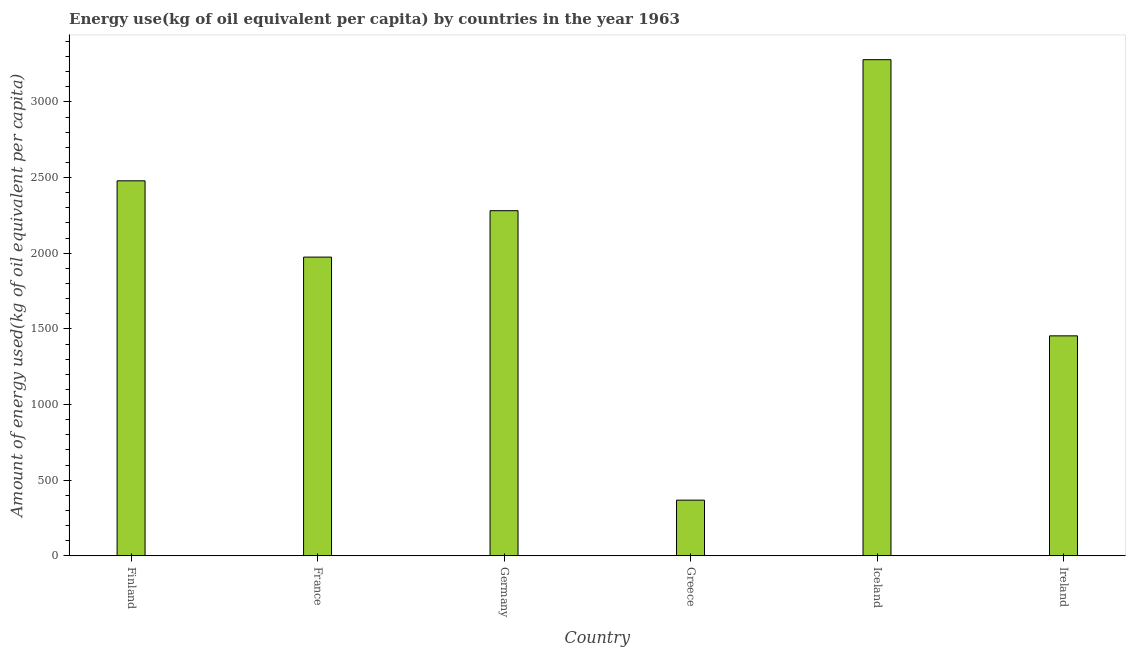Does the graph contain any zero values?
Give a very brief answer. No. Does the graph contain grids?
Provide a succinct answer. No. What is the title of the graph?
Provide a short and direct response. Energy use(kg of oil equivalent per capita) by countries in the year 1963. What is the label or title of the Y-axis?
Your response must be concise. Amount of energy used(kg of oil equivalent per capita). What is the amount of energy used in France?
Offer a terse response. 1974.48. Across all countries, what is the maximum amount of energy used?
Offer a very short reply. 3279.6. Across all countries, what is the minimum amount of energy used?
Ensure brevity in your answer.  367.81. What is the sum of the amount of energy used?
Ensure brevity in your answer.  1.18e+04. What is the difference between the amount of energy used in Finland and Ireland?
Your answer should be compact. 1024.95. What is the average amount of energy used per country?
Your response must be concise. 1972.68. What is the median amount of energy used?
Your response must be concise. 2127.89. In how many countries, is the amount of energy used greater than 2900 kg?
Your response must be concise. 1. What is the ratio of the amount of energy used in Germany to that in Iceland?
Give a very brief answer. 0.7. Is the amount of energy used in Finland less than that in Ireland?
Give a very brief answer. No. Is the difference between the amount of energy used in Finland and Ireland greater than the difference between any two countries?
Your response must be concise. No. What is the difference between the highest and the second highest amount of energy used?
Ensure brevity in your answer.  800.69. Is the sum of the amount of energy used in Finland and Iceland greater than the maximum amount of energy used across all countries?
Offer a very short reply. Yes. What is the difference between the highest and the lowest amount of energy used?
Offer a very short reply. 2911.79. In how many countries, is the amount of energy used greater than the average amount of energy used taken over all countries?
Your response must be concise. 4. How many bars are there?
Provide a short and direct response. 6. How many countries are there in the graph?
Keep it short and to the point. 6. What is the difference between two consecutive major ticks on the Y-axis?
Make the answer very short. 500. What is the Amount of energy used(kg of oil equivalent per capita) of Finland?
Provide a succinct answer. 2478.91. What is the Amount of energy used(kg of oil equivalent per capita) in France?
Your answer should be very brief. 1974.48. What is the Amount of energy used(kg of oil equivalent per capita) of Germany?
Offer a very short reply. 2281.29. What is the Amount of energy used(kg of oil equivalent per capita) in Greece?
Offer a very short reply. 367.81. What is the Amount of energy used(kg of oil equivalent per capita) in Iceland?
Your response must be concise. 3279.6. What is the Amount of energy used(kg of oil equivalent per capita) of Ireland?
Make the answer very short. 1453.96. What is the difference between the Amount of energy used(kg of oil equivalent per capita) in Finland and France?
Keep it short and to the point. 504.43. What is the difference between the Amount of energy used(kg of oil equivalent per capita) in Finland and Germany?
Give a very brief answer. 197.62. What is the difference between the Amount of energy used(kg of oil equivalent per capita) in Finland and Greece?
Offer a terse response. 2111.1. What is the difference between the Amount of energy used(kg of oil equivalent per capita) in Finland and Iceland?
Make the answer very short. -800.69. What is the difference between the Amount of energy used(kg of oil equivalent per capita) in Finland and Ireland?
Ensure brevity in your answer.  1024.95. What is the difference between the Amount of energy used(kg of oil equivalent per capita) in France and Germany?
Offer a very short reply. -306.81. What is the difference between the Amount of energy used(kg of oil equivalent per capita) in France and Greece?
Ensure brevity in your answer.  1606.67. What is the difference between the Amount of energy used(kg of oil equivalent per capita) in France and Iceland?
Provide a succinct answer. -1305.12. What is the difference between the Amount of energy used(kg of oil equivalent per capita) in France and Ireland?
Provide a succinct answer. 520.52. What is the difference between the Amount of energy used(kg of oil equivalent per capita) in Germany and Greece?
Your response must be concise. 1913.48. What is the difference between the Amount of energy used(kg of oil equivalent per capita) in Germany and Iceland?
Offer a terse response. -998.31. What is the difference between the Amount of energy used(kg of oil equivalent per capita) in Germany and Ireland?
Give a very brief answer. 827.33. What is the difference between the Amount of energy used(kg of oil equivalent per capita) in Greece and Iceland?
Offer a terse response. -2911.79. What is the difference between the Amount of energy used(kg of oil equivalent per capita) in Greece and Ireland?
Your answer should be very brief. -1086.15. What is the difference between the Amount of energy used(kg of oil equivalent per capita) in Iceland and Ireland?
Offer a very short reply. 1825.64. What is the ratio of the Amount of energy used(kg of oil equivalent per capita) in Finland to that in France?
Your answer should be very brief. 1.25. What is the ratio of the Amount of energy used(kg of oil equivalent per capita) in Finland to that in Germany?
Offer a very short reply. 1.09. What is the ratio of the Amount of energy used(kg of oil equivalent per capita) in Finland to that in Greece?
Ensure brevity in your answer.  6.74. What is the ratio of the Amount of energy used(kg of oil equivalent per capita) in Finland to that in Iceland?
Provide a short and direct response. 0.76. What is the ratio of the Amount of energy used(kg of oil equivalent per capita) in Finland to that in Ireland?
Your response must be concise. 1.71. What is the ratio of the Amount of energy used(kg of oil equivalent per capita) in France to that in Germany?
Ensure brevity in your answer.  0.87. What is the ratio of the Amount of energy used(kg of oil equivalent per capita) in France to that in Greece?
Give a very brief answer. 5.37. What is the ratio of the Amount of energy used(kg of oil equivalent per capita) in France to that in Iceland?
Keep it short and to the point. 0.6. What is the ratio of the Amount of energy used(kg of oil equivalent per capita) in France to that in Ireland?
Provide a short and direct response. 1.36. What is the ratio of the Amount of energy used(kg of oil equivalent per capita) in Germany to that in Greece?
Provide a succinct answer. 6.2. What is the ratio of the Amount of energy used(kg of oil equivalent per capita) in Germany to that in Iceland?
Provide a short and direct response. 0.7. What is the ratio of the Amount of energy used(kg of oil equivalent per capita) in Germany to that in Ireland?
Offer a very short reply. 1.57. What is the ratio of the Amount of energy used(kg of oil equivalent per capita) in Greece to that in Iceland?
Provide a short and direct response. 0.11. What is the ratio of the Amount of energy used(kg of oil equivalent per capita) in Greece to that in Ireland?
Your answer should be compact. 0.25. What is the ratio of the Amount of energy used(kg of oil equivalent per capita) in Iceland to that in Ireland?
Offer a terse response. 2.26. 